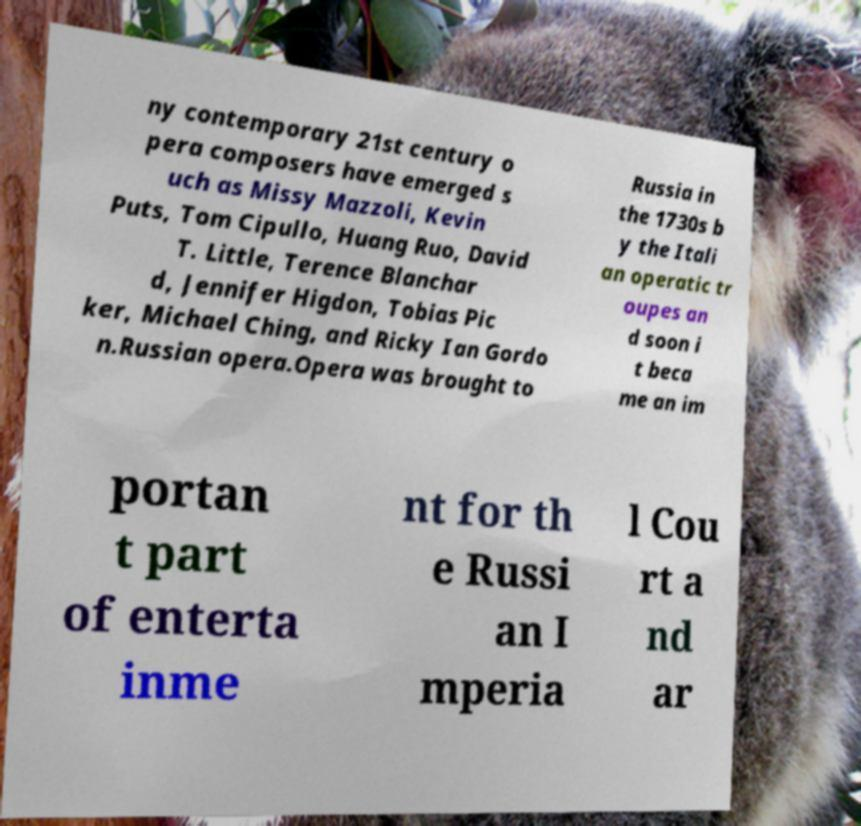Can you accurately transcribe the text from the provided image for me? ny contemporary 21st century o pera composers have emerged s uch as Missy Mazzoli, Kevin Puts, Tom Cipullo, Huang Ruo, David T. Little, Terence Blanchar d, Jennifer Higdon, Tobias Pic ker, Michael Ching, and Ricky Ian Gordo n.Russian opera.Opera was brought to Russia in the 1730s b y the Itali an operatic tr oupes an d soon i t beca me an im portan t part of enterta inme nt for th e Russi an I mperia l Cou rt a nd ar 